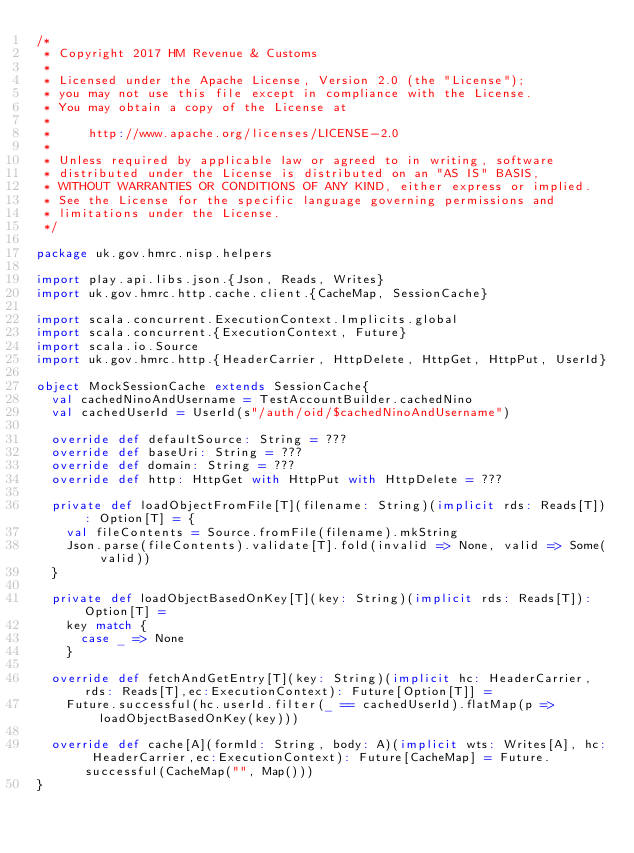Convert code to text. <code><loc_0><loc_0><loc_500><loc_500><_Scala_>/*
 * Copyright 2017 HM Revenue & Customs
 *
 * Licensed under the Apache License, Version 2.0 (the "License");
 * you may not use this file except in compliance with the License.
 * You may obtain a copy of the License at
 *
 *     http://www.apache.org/licenses/LICENSE-2.0
 *
 * Unless required by applicable law or agreed to in writing, software
 * distributed under the License is distributed on an "AS IS" BASIS,
 * WITHOUT WARRANTIES OR CONDITIONS OF ANY KIND, either express or implied.
 * See the License for the specific language governing permissions and
 * limitations under the License.
 */

package uk.gov.hmrc.nisp.helpers

import play.api.libs.json.{Json, Reads, Writes}
import uk.gov.hmrc.http.cache.client.{CacheMap, SessionCache}

import scala.concurrent.ExecutionContext.Implicits.global
import scala.concurrent.{ExecutionContext, Future}
import scala.io.Source
import uk.gov.hmrc.http.{HeaderCarrier, HttpDelete, HttpGet, HttpPut, UserId}

object MockSessionCache extends SessionCache{
  val cachedNinoAndUsername = TestAccountBuilder.cachedNino
  val cachedUserId = UserId(s"/auth/oid/$cachedNinoAndUsername")

  override def defaultSource: String = ???
  override def baseUri: String = ???
  override def domain: String = ???
  override def http: HttpGet with HttpPut with HttpDelete = ???

  private def loadObjectFromFile[T](filename: String)(implicit rds: Reads[T]): Option[T] = {
    val fileContents = Source.fromFile(filename).mkString
    Json.parse(fileContents).validate[T].fold(invalid => None, valid => Some(valid))
  }

  private def loadObjectBasedOnKey[T](key: String)(implicit rds: Reads[T]): Option[T] =
    key match {
      case _ => None
    }

  override def fetchAndGetEntry[T](key: String)(implicit hc: HeaderCarrier, rds: Reads[T],ec:ExecutionContext): Future[Option[T]] =
    Future.successful(hc.userId.filter(_ == cachedUserId).flatMap(p => loadObjectBasedOnKey(key)))

  override def cache[A](formId: String, body: A)(implicit wts: Writes[A], hc: HeaderCarrier,ec:ExecutionContext): Future[CacheMap] = Future.successful(CacheMap("", Map()))
}
</code> 